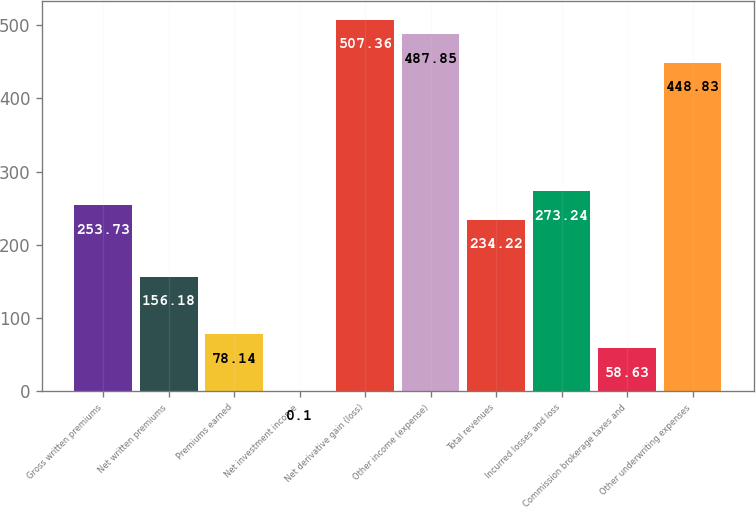Convert chart. <chart><loc_0><loc_0><loc_500><loc_500><bar_chart><fcel>Gross written premiums<fcel>Net written premiums<fcel>Premiums earned<fcel>Net investment income<fcel>Net derivative gain (loss)<fcel>Other income (expense)<fcel>Total revenues<fcel>Incurred losses and loss<fcel>Commission brokerage taxes and<fcel>Other underwriting expenses<nl><fcel>253.73<fcel>156.18<fcel>78.14<fcel>0.1<fcel>507.36<fcel>487.85<fcel>234.22<fcel>273.24<fcel>58.63<fcel>448.83<nl></chart> 